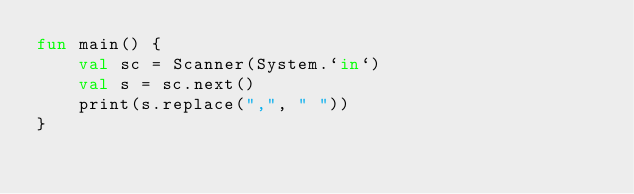Convert code to text. <code><loc_0><loc_0><loc_500><loc_500><_Kotlin_>fun main() {
    val sc = Scanner(System.`in`)
    val s = sc.next()
    print(s.replace(",", " "))
}</code> 